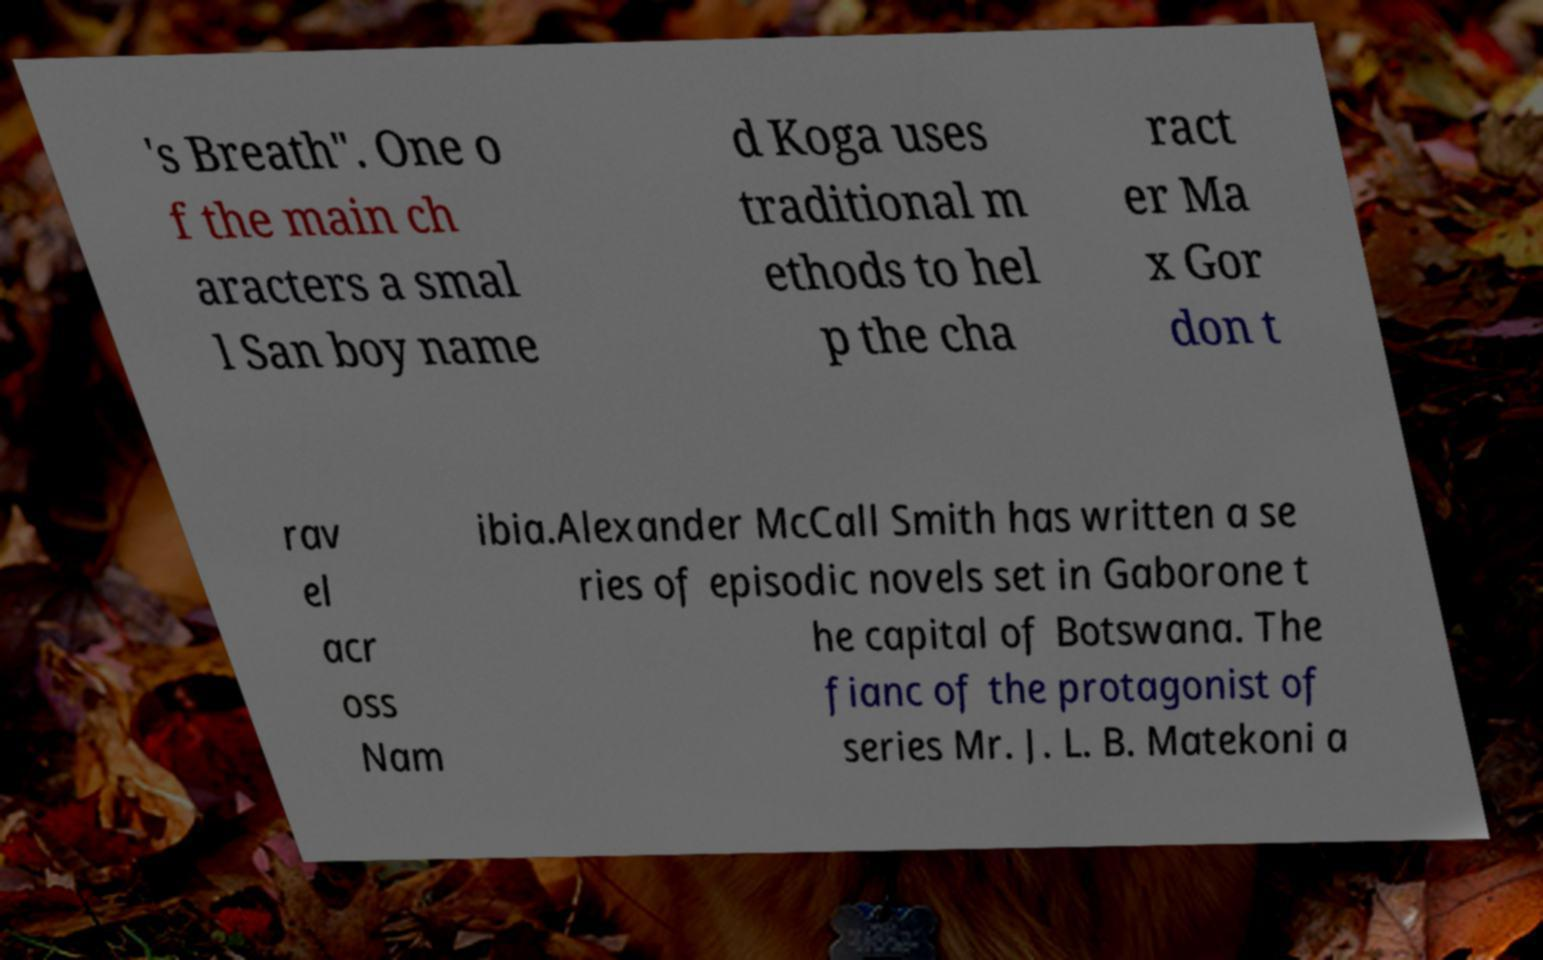Can you accurately transcribe the text from the provided image for me? 's Breath". One o f the main ch aracters a smal l San boy name d Koga uses traditional m ethods to hel p the cha ract er Ma x Gor don t rav el acr oss Nam ibia.Alexander McCall Smith has written a se ries of episodic novels set in Gaborone t he capital of Botswana. The fianc of the protagonist of series Mr. J. L. B. Matekoni a 